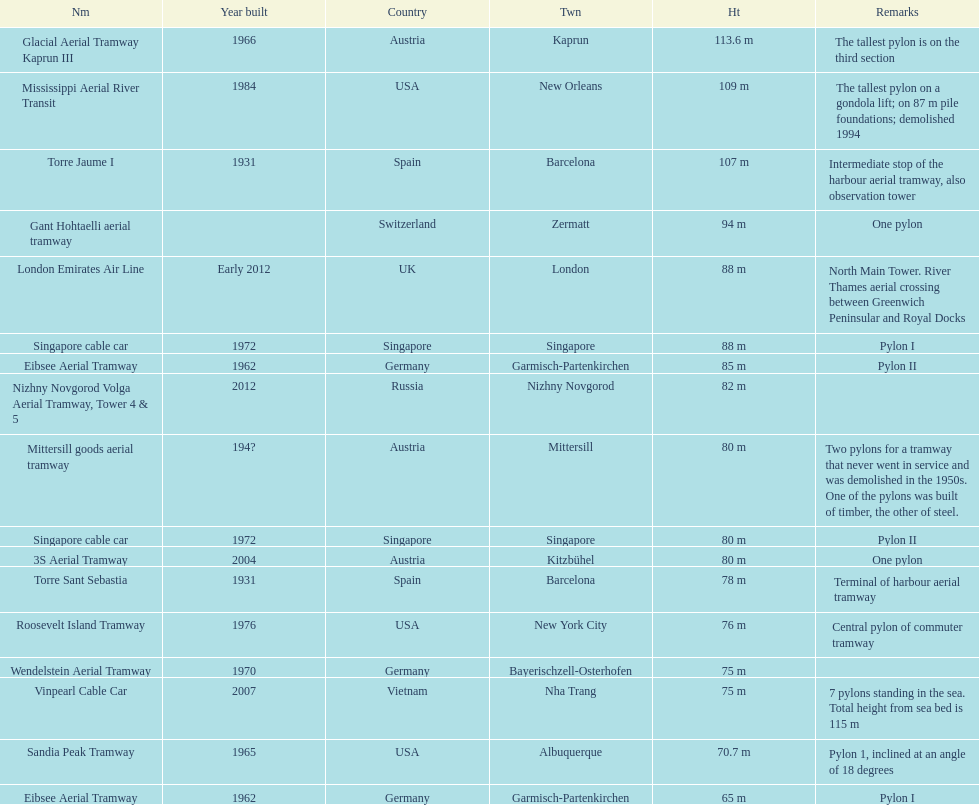What is the total number of pylons listed? 17. 